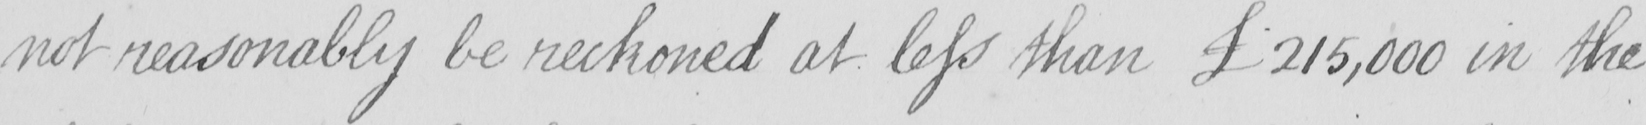What is written in this line of handwriting? not reasonably be reckoned at less than £215,000 in the 